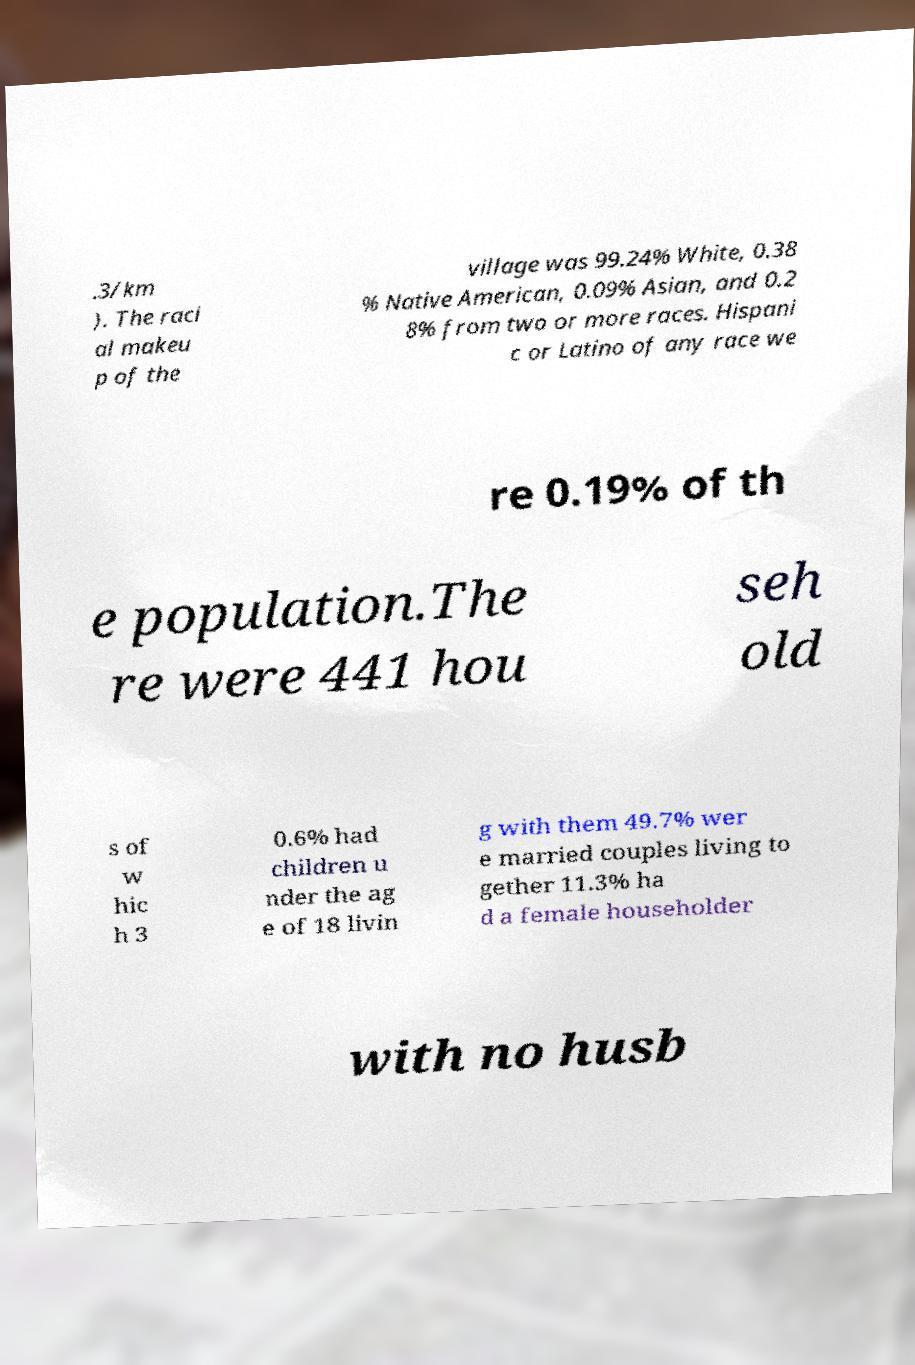Can you accurately transcribe the text from the provided image for me? .3/km ). The raci al makeu p of the village was 99.24% White, 0.38 % Native American, 0.09% Asian, and 0.2 8% from two or more races. Hispani c or Latino of any race we re 0.19% of th e population.The re were 441 hou seh old s of w hic h 3 0.6% had children u nder the ag e of 18 livin g with them 49.7% wer e married couples living to gether 11.3% ha d a female householder with no husb 